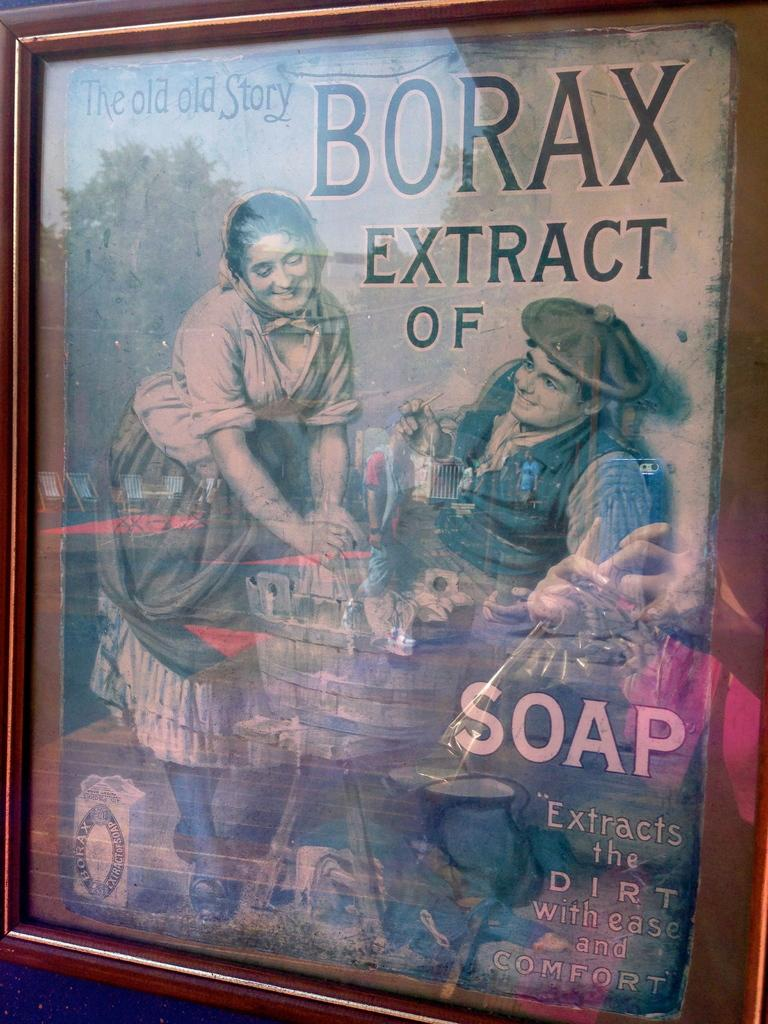<image>
Render a clear and concise summary of the photo. A framed advertisement of Borax Extract of Soap. 